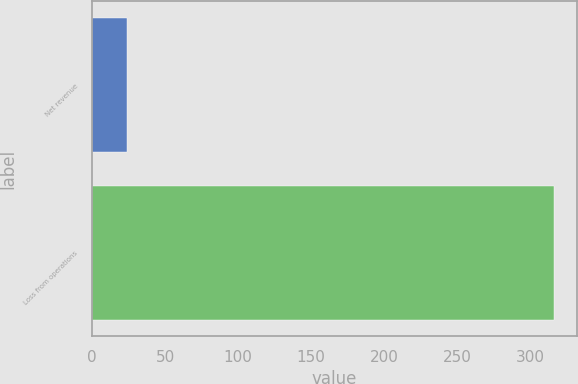Convert chart to OTSL. <chart><loc_0><loc_0><loc_500><loc_500><bar_chart><fcel>Net revenue<fcel>Loss from operations<nl><fcel>24<fcel>316<nl></chart> 